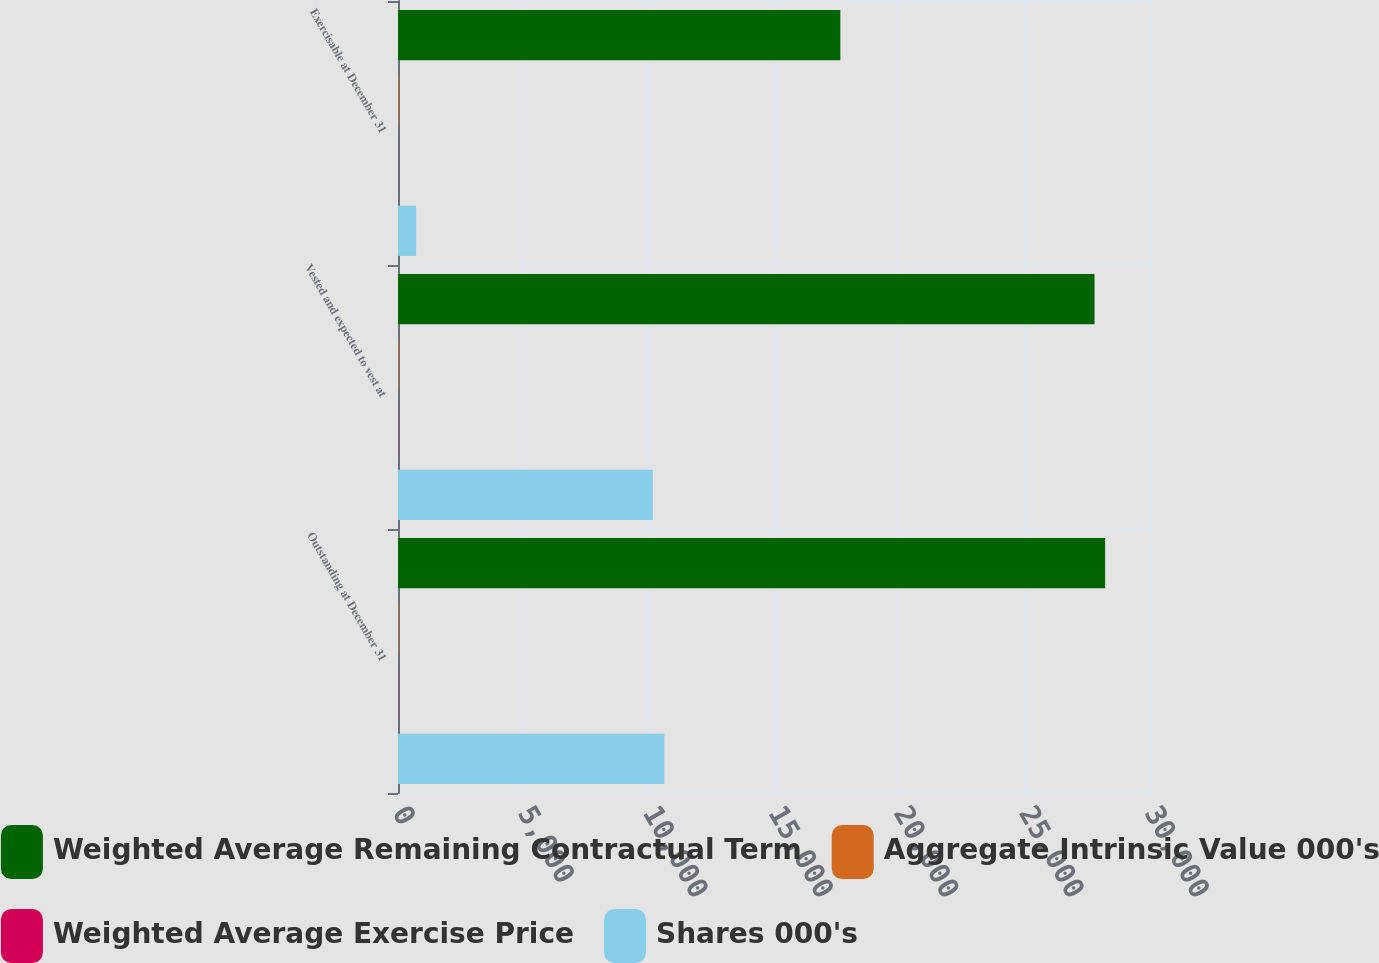Convert chart. <chart><loc_0><loc_0><loc_500><loc_500><stacked_bar_chart><ecel><fcel>Outstanding at December 31<fcel>Vested and expected to vest at<fcel>Exercisable at December 31<nl><fcel>Weighted Average Remaining Contractual Term<fcel>28211<fcel>27786<fcel>17647<nl><fcel>Aggregate Intrinsic Value 000's<fcel>23.17<fcel>23.33<fcel>25.42<nl><fcel>Weighted Average Exercise Price<fcel>3.85<fcel>3.82<fcel>2.88<nl><fcel>Shares 000's<fcel>10627<fcel>10166<fcel>723<nl></chart> 